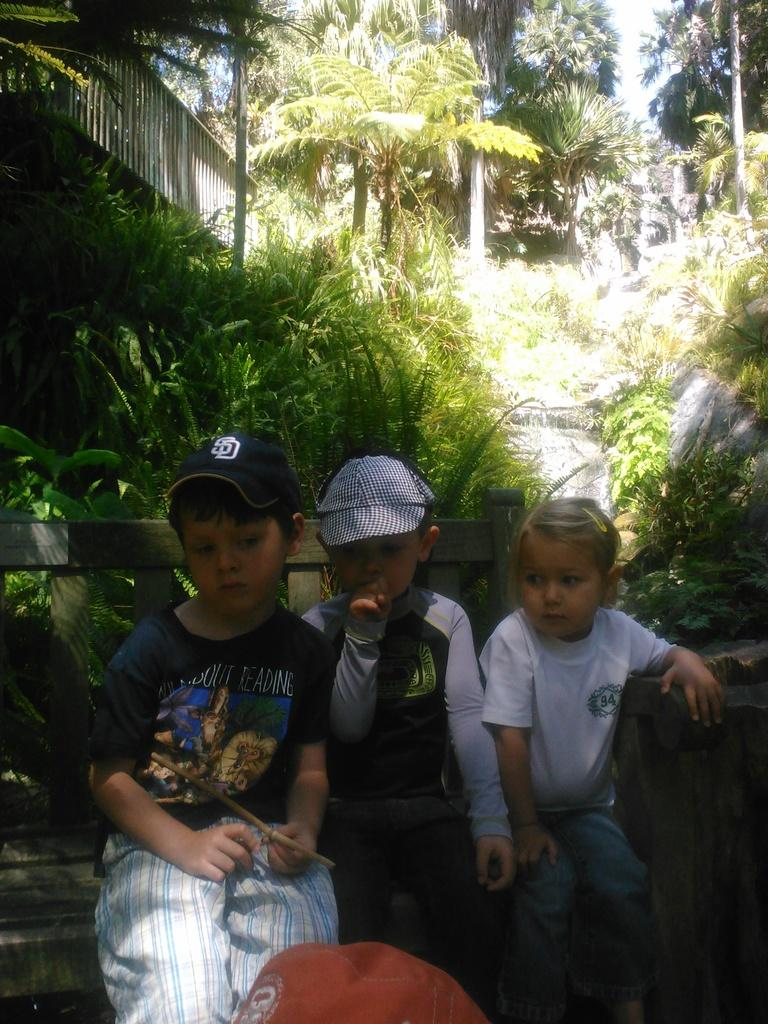How many children are in the image? There are 3 children in the image. What are the children sitting on? The children are sitting on a wooden bench. What can be seen in the background of the image? There are trees visible in the background. What is on the left side of the image? There is a wooden fence on the left side of the image. What type of honey is being used to respect the wooden bench in the image? There is no honey or respect being shown to the wooden bench in the image; it is simply a bench where the children are sitting. 